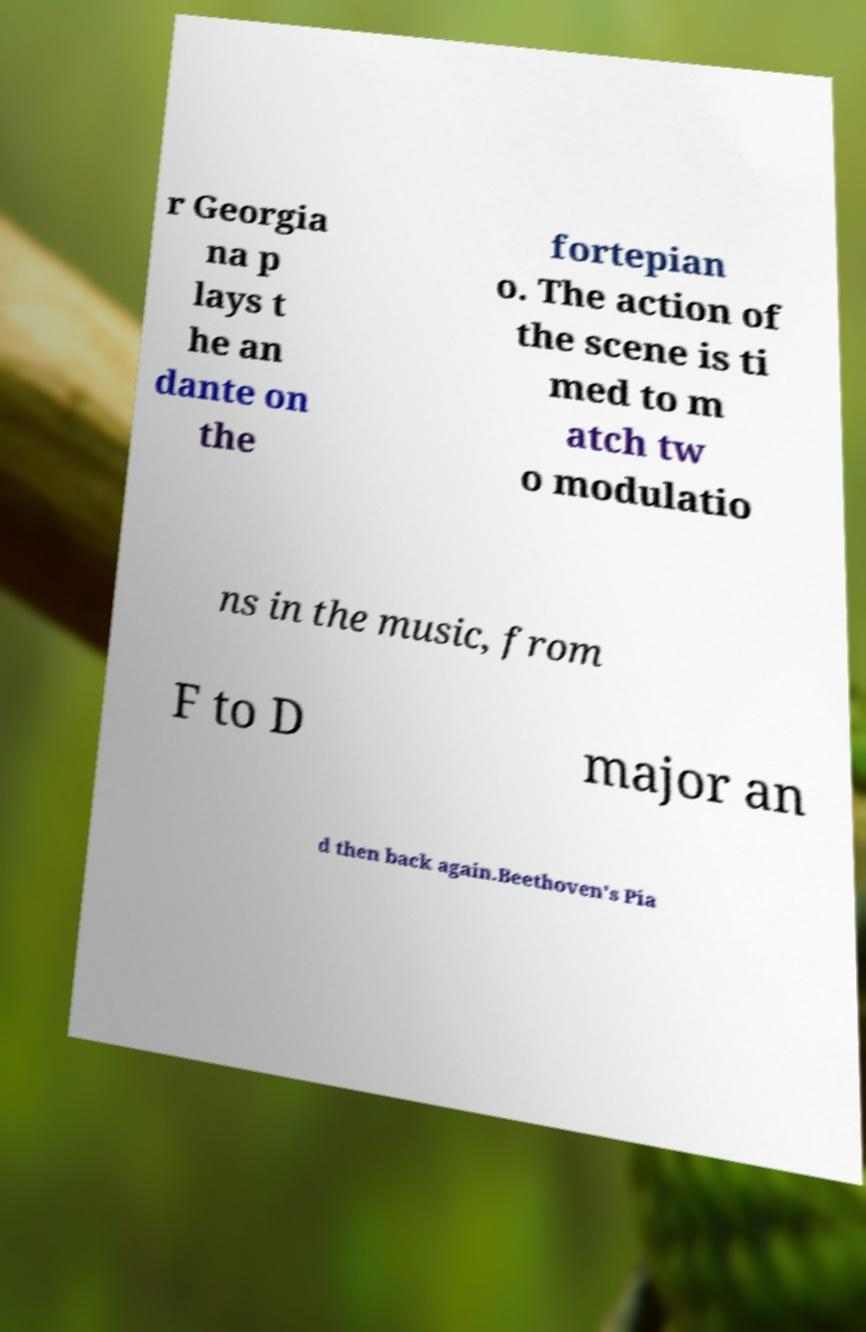Could you assist in decoding the text presented in this image and type it out clearly? r Georgia na p lays t he an dante on the fortepian o. The action of the scene is ti med to m atch tw o modulatio ns in the music, from F to D major an d then back again.Beethoven's Pia 